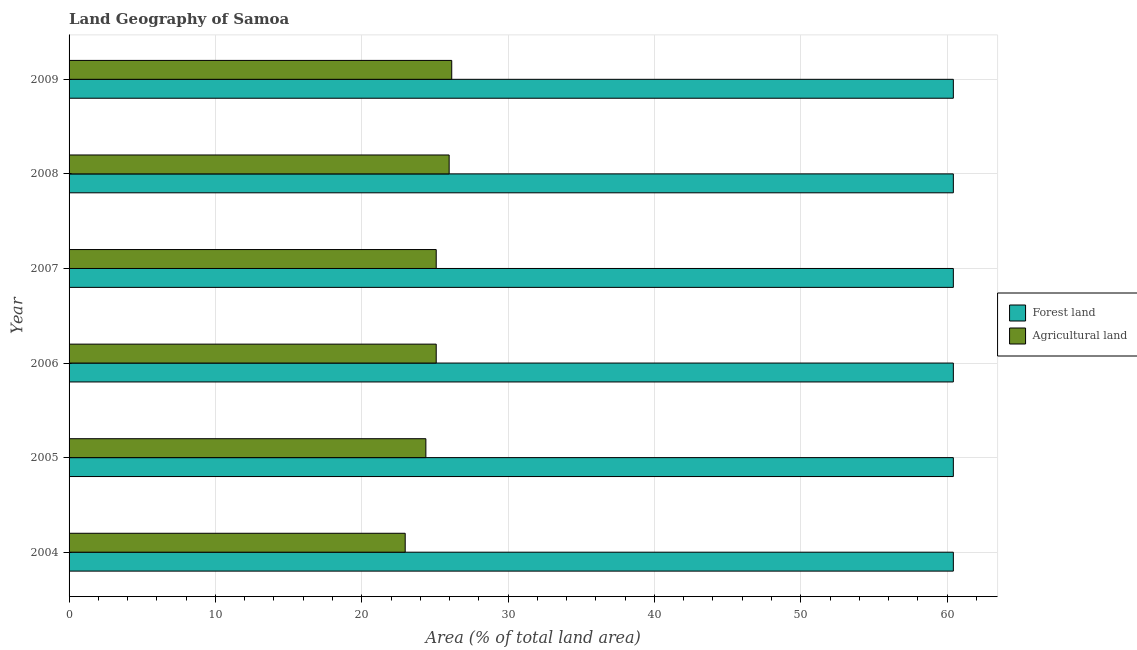Are the number of bars per tick equal to the number of legend labels?
Your response must be concise. Yes. Are the number of bars on each tick of the Y-axis equal?
Give a very brief answer. Yes. How many bars are there on the 2nd tick from the top?
Your response must be concise. 2. What is the label of the 2nd group of bars from the top?
Your answer should be very brief. 2008. What is the percentage of land area under agriculture in 2007?
Your response must be concise. 25.09. Across all years, what is the maximum percentage of land area under agriculture?
Make the answer very short. 26.15. Across all years, what is the minimum percentage of land area under agriculture?
Offer a terse response. 22.97. In which year was the percentage of land area under forests minimum?
Offer a terse response. 2004. What is the total percentage of land area under forests in the graph?
Ensure brevity in your answer.  362.54. What is the difference between the percentage of land area under agriculture in 2006 and that in 2008?
Your answer should be compact. -0.88. What is the difference between the percentage of land area under agriculture in 2004 and the percentage of land area under forests in 2006?
Offer a very short reply. -37.46. What is the average percentage of land area under agriculture per year?
Ensure brevity in your answer.  24.94. In the year 2008, what is the difference between the percentage of land area under forests and percentage of land area under agriculture?
Provide a short and direct response. 34.45. In how many years, is the percentage of land area under agriculture greater than 34 %?
Keep it short and to the point. 0. What is the ratio of the percentage of land area under agriculture in 2004 to that in 2009?
Make the answer very short. 0.88. Is the difference between the percentage of land area under agriculture in 2004 and 2008 greater than the difference between the percentage of land area under forests in 2004 and 2008?
Give a very brief answer. No. What is the difference between the highest and the lowest percentage of land area under agriculture?
Make the answer very short. 3.18. In how many years, is the percentage of land area under forests greater than the average percentage of land area under forests taken over all years?
Your answer should be very brief. 6. What does the 1st bar from the top in 2007 represents?
Give a very brief answer. Agricultural land. What does the 1st bar from the bottom in 2009 represents?
Provide a succinct answer. Forest land. How many years are there in the graph?
Provide a succinct answer. 6. What is the difference between two consecutive major ticks on the X-axis?
Your answer should be compact. 10. Does the graph contain grids?
Your response must be concise. Yes. Where does the legend appear in the graph?
Your answer should be very brief. Center right. How many legend labels are there?
Offer a terse response. 2. How are the legend labels stacked?
Ensure brevity in your answer.  Vertical. What is the title of the graph?
Keep it short and to the point. Land Geography of Samoa. What is the label or title of the X-axis?
Ensure brevity in your answer.  Area (% of total land area). What is the Area (% of total land area) in Forest land in 2004?
Offer a very short reply. 60.42. What is the Area (% of total land area) in Agricultural land in 2004?
Ensure brevity in your answer.  22.97. What is the Area (% of total land area) in Forest land in 2005?
Ensure brevity in your answer.  60.42. What is the Area (% of total land area) in Agricultural land in 2005?
Offer a terse response. 24.38. What is the Area (% of total land area) in Forest land in 2006?
Keep it short and to the point. 60.42. What is the Area (% of total land area) of Agricultural land in 2006?
Offer a terse response. 25.09. What is the Area (% of total land area) of Forest land in 2007?
Give a very brief answer. 60.42. What is the Area (% of total land area) of Agricultural land in 2007?
Give a very brief answer. 25.09. What is the Area (% of total land area) of Forest land in 2008?
Offer a terse response. 60.42. What is the Area (% of total land area) of Agricultural land in 2008?
Your answer should be compact. 25.97. What is the Area (% of total land area) in Forest land in 2009?
Offer a terse response. 60.42. What is the Area (% of total land area) of Agricultural land in 2009?
Ensure brevity in your answer.  26.15. Across all years, what is the maximum Area (% of total land area) in Forest land?
Provide a succinct answer. 60.42. Across all years, what is the maximum Area (% of total land area) in Agricultural land?
Offer a very short reply. 26.15. Across all years, what is the minimum Area (% of total land area) in Forest land?
Ensure brevity in your answer.  60.42. Across all years, what is the minimum Area (% of total land area) in Agricultural land?
Provide a short and direct response. 22.97. What is the total Area (% of total land area) in Forest land in the graph?
Offer a very short reply. 362.54. What is the total Area (% of total land area) in Agricultural land in the graph?
Offer a terse response. 149.65. What is the difference between the Area (% of total land area) in Forest land in 2004 and that in 2005?
Offer a very short reply. 0. What is the difference between the Area (% of total land area) of Agricultural land in 2004 and that in 2005?
Keep it short and to the point. -1.41. What is the difference between the Area (% of total land area) of Forest land in 2004 and that in 2006?
Make the answer very short. 0. What is the difference between the Area (% of total land area) in Agricultural land in 2004 and that in 2006?
Your answer should be compact. -2.12. What is the difference between the Area (% of total land area) in Agricultural land in 2004 and that in 2007?
Make the answer very short. -2.12. What is the difference between the Area (% of total land area) in Forest land in 2004 and that in 2008?
Your answer should be very brief. 0. What is the difference between the Area (% of total land area) in Agricultural land in 2004 and that in 2008?
Your answer should be compact. -3. What is the difference between the Area (% of total land area) in Agricultural land in 2004 and that in 2009?
Provide a short and direct response. -3.18. What is the difference between the Area (% of total land area) of Agricultural land in 2005 and that in 2006?
Your answer should be very brief. -0.71. What is the difference between the Area (% of total land area) in Agricultural land in 2005 and that in 2007?
Keep it short and to the point. -0.71. What is the difference between the Area (% of total land area) of Forest land in 2005 and that in 2008?
Offer a very short reply. 0. What is the difference between the Area (% of total land area) of Agricultural land in 2005 and that in 2008?
Your answer should be very brief. -1.59. What is the difference between the Area (% of total land area) of Agricultural land in 2005 and that in 2009?
Provide a succinct answer. -1.77. What is the difference between the Area (% of total land area) in Forest land in 2006 and that in 2007?
Ensure brevity in your answer.  0. What is the difference between the Area (% of total land area) of Agricultural land in 2006 and that in 2007?
Your answer should be very brief. 0. What is the difference between the Area (% of total land area) in Agricultural land in 2006 and that in 2008?
Provide a short and direct response. -0.88. What is the difference between the Area (% of total land area) in Agricultural land in 2006 and that in 2009?
Your response must be concise. -1.06. What is the difference between the Area (% of total land area) of Agricultural land in 2007 and that in 2008?
Provide a short and direct response. -0.88. What is the difference between the Area (% of total land area) of Agricultural land in 2007 and that in 2009?
Keep it short and to the point. -1.06. What is the difference between the Area (% of total land area) of Forest land in 2008 and that in 2009?
Make the answer very short. 0. What is the difference between the Area (% of total land area) in Agricultural land in 2008 and that in 2009?
Make the answer very short. -0.18. What is the difference between the Area (% of total land area) of Forest land in 2004 and the Area (% of total land area) of Agricultural land in 2005?
Make the answer very short. 36.04. What is the difference between the Area (% of total land area) in Forest land in 2004 and the Area (% of total land area) in Agricultural land in 2006?
Give a very brief answer. 35.34. What is the difference between the Area (% of total land area) in Forest land in 2004 and the Area (% of total land area) in Agricultural land in 2007?
Give a very brief answer. 35.34. What is the difference between the Area (% of total land area) in Forest land in 2004 and the Area (% of total land area) in Agricultural land in 2008?
Your answer should be compact. 34.45. What is the difference between the Area (% of total land area) in Forest land in 2004 and the Area (% of total land area) in Agricultural land in 2009?
Your response must be concise. 34.28. What is the difference between the Area (% of total land area) of Forest land in 2005 and the Area (% of total land area) of Agricultural land in 2006?
Your answer should be very brief. 35.34. What is the difference between the Area (% of total land area) of Forest land in 2005 and the Area (% of total land area) of Agricultural land in 2007?
Make the answer very short. 35.34. What is the difference between the Area (% of total land area) in Forest land in 2005 and the Area (% of total land area) in Agricultural land in 2008?
Your response must be concise. 34.45. What is the difference between the Area (% of total land area) of Forest land in 2005 and the Area (% of total land area) of Agricultural land in 2009?
Your response must be concise. 34.28. What is the difference between the Area (% of total land area) in Forest land in 2006 and the Area (% of total land area) in Agricultural land in 2007?
Your answer should be very brief. 35.34. What is the difference between the Area (% of total land area) in Forest land in 2006 and the Area (% of total land area) in Agricultural land in 2008?
Give a very brief answer. 34.45. What is the difference between the Area (% of total land area) in Forest land in 2006 and the Area (% of total land area) in Agricultural land in 2009?
Your response must be concise. 34.28. What is the difference between the Area (% of total land area) in Forest land in 2007 and the Area (% of total land area) in Agricultural land in 2008?
Make the answer very short. 34.45. What is the difference between the Area (% of total land area) of Forest land in 2007 and the Area (% of total land area) of Agricultural land in 2009?
Give a very brief answer. 34.28. What is the difference between the Area (% of total land area) of Forest land in 2008 and the Area (% of total land area) of Agricultural land in 2009?
Your answer should be very brief. 34.28. What is the average Area (% of total land area) in Forest land per year?
Offer a very short reply. 60.42. What is the average Area (% of total land area) of Agricultural land per year?
Keep it short and to the point. 24.94. In the year 2004, what is the difference between the Area (% of total land area) in Forest land and Area (% of total land area) in Agricultural land?
Your answer should be compact. 37.46. In the year 2005, what is the difference between the Area (% of total land area) in Forest land and Area (% of total land area) in Agricultural land?
Give a very brief answer. 36.04. In the year 2006, what is the difference between the Area (% of total land area) in Forest land and Area (% of total land area) in Agricultural land?
Your response must be concise. 35.34. In the year 2007, what is the difference between the Area (% of total land area) in Forest land and Area (% of total land area) in Agricultural land?
Ensure brevity in your answer.  35.34. In the year 2008, what is the difference between the Area (% of total land area) of Forest land and Area (% of total land area) of Agricultural land?
Give a very brief answer. 34.45. In the year 2009, what is the difference between the Area (% of total land area) of Forest land and Area (% of total land area) of Agricultural land?
Ensure brevity in your answer.  34.28. What is the ratio of the Area (% of total land area) in Agricultural land in 2004 to that in 2005?
Provide a short and direct response. 0.94. What is the ratio of the Area (% of total land area) of Agricultural land in 2004 to that in 2006?
Provide a succinct answer. 0.92. What is the ratio of the Area (% of total land area) in Forest land in 2004 to that in 2007?
Offer a terse response. 1. What is the ratio of the Area (% of total land area) of Agricultural land in 2004 to that in 2007?
Provide a succinct answer. 0.92. What is the ratio of the Area (% of total land area) in Agricultural land in 2004 to that in 2008?
Your answer should be compact. 0.88. What is the ratio of the Area (% of total land area) in Agricultural land in 2004 to that in 2009?
Ensure brevity in your answer.  0.88. What is the ratio of the Area (% of total land area) of Forest land in 2005 to that in 2006?
Offer a very short reply. 1. What is the ratio of the Area (% of total land area) of Agricultural land in 2005 to that in 2006?
Give a very brief answer. 0.97. What is the ratio of the Area (% of total land area) of Forest land in 2005 to that in 2007?
Keep it short and to the point. 1. What is the ratio of the Area (% of total land area) of Agricultural land in 2005 to that in 2007?
Offer a terse response. 0.97. What is the ratio of the Area (% of total land area) of Agricultural land in 2005 to that in 2008?
Provide a succinct answer. 0.94. What is the ratio of the Area (% of total land area) in Forest land in 2005 to that in 2009?
Keep it short and to the point. 1. What is the ratio of the Area (% of total land area) in Agricultural land in 2005 to that in 2009?
Your answer should be compact. 0.93. What is the ratio of the Area (% of total land area) in Forest land in 2006 to that in 2007?
Offer a very short reply. 1. What is the ratio of the Area (% of total land area) in Agricultural land in 2006 to that in 2007?
Your answer should be compact. 1. What is the ratio of the Area (% of total land area) of Agricultural land in 2006 to that in 2009?
Ensure brevity in your answer.  0.96. What is the ratio of the Area (% of total land area) in Forest land in 2007 to that in 2008?
Give a very brief answer. 1. What is the ratio of the Area (% of total land area) of Agricultural land in 2007 to that in 2008?
Your answer should be compact. 0.97. What is the ratio of the Area (% of total land area) of Agricultural land in 2007 to that in 2009?
Ensure brevity in your answer.  0.96. What is the ratio of the Area (% of total land area) in Forest land in 2008 to that in 2009?
Ensure brevity in your answer.  1. What is the difference between the highest and the second highest Area (% of total land area) in Agricultural land?
Give a very brief answer. 0.18. What is the difference between the highest and the lowest Area (% of total land area) of Forest land?
Ensure brevity in your answer.  0. What is the difference between the highest and the lowest Area (% of total land area) in Agricultural land?
Ensure brevity in your answer.  3.18. 